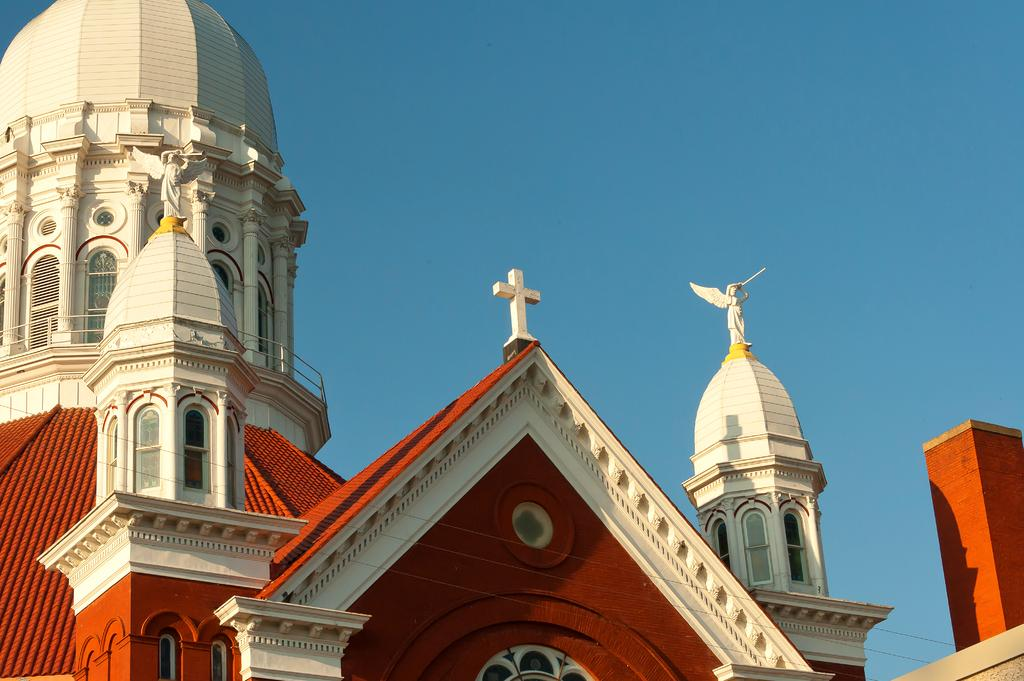What is there is a structure in the image, what is it? There is a building in the image. What can be seen above the building in the image? The sky is visible at the top of the image. What type of club is being used to hit the carriage in the image? There is no club or carriage present in the image. What type of cloud can be seen in the image? The provided facts do not mention any clouds in the image. 